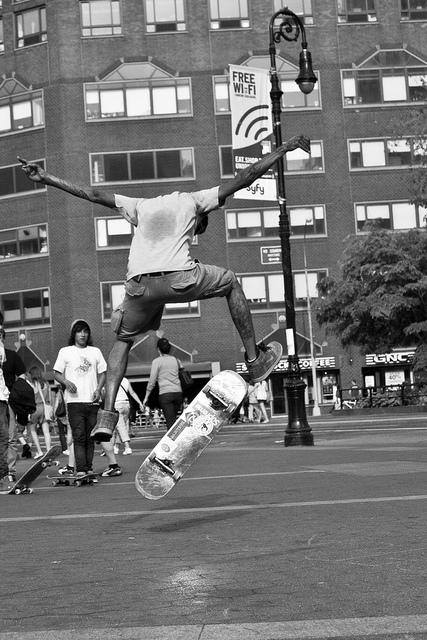What type of goods are sold in the store next to the tree? Please explain your reasoning. nutritional supplements. The name of the store is visible and the goods sold within the store can be discerned. 